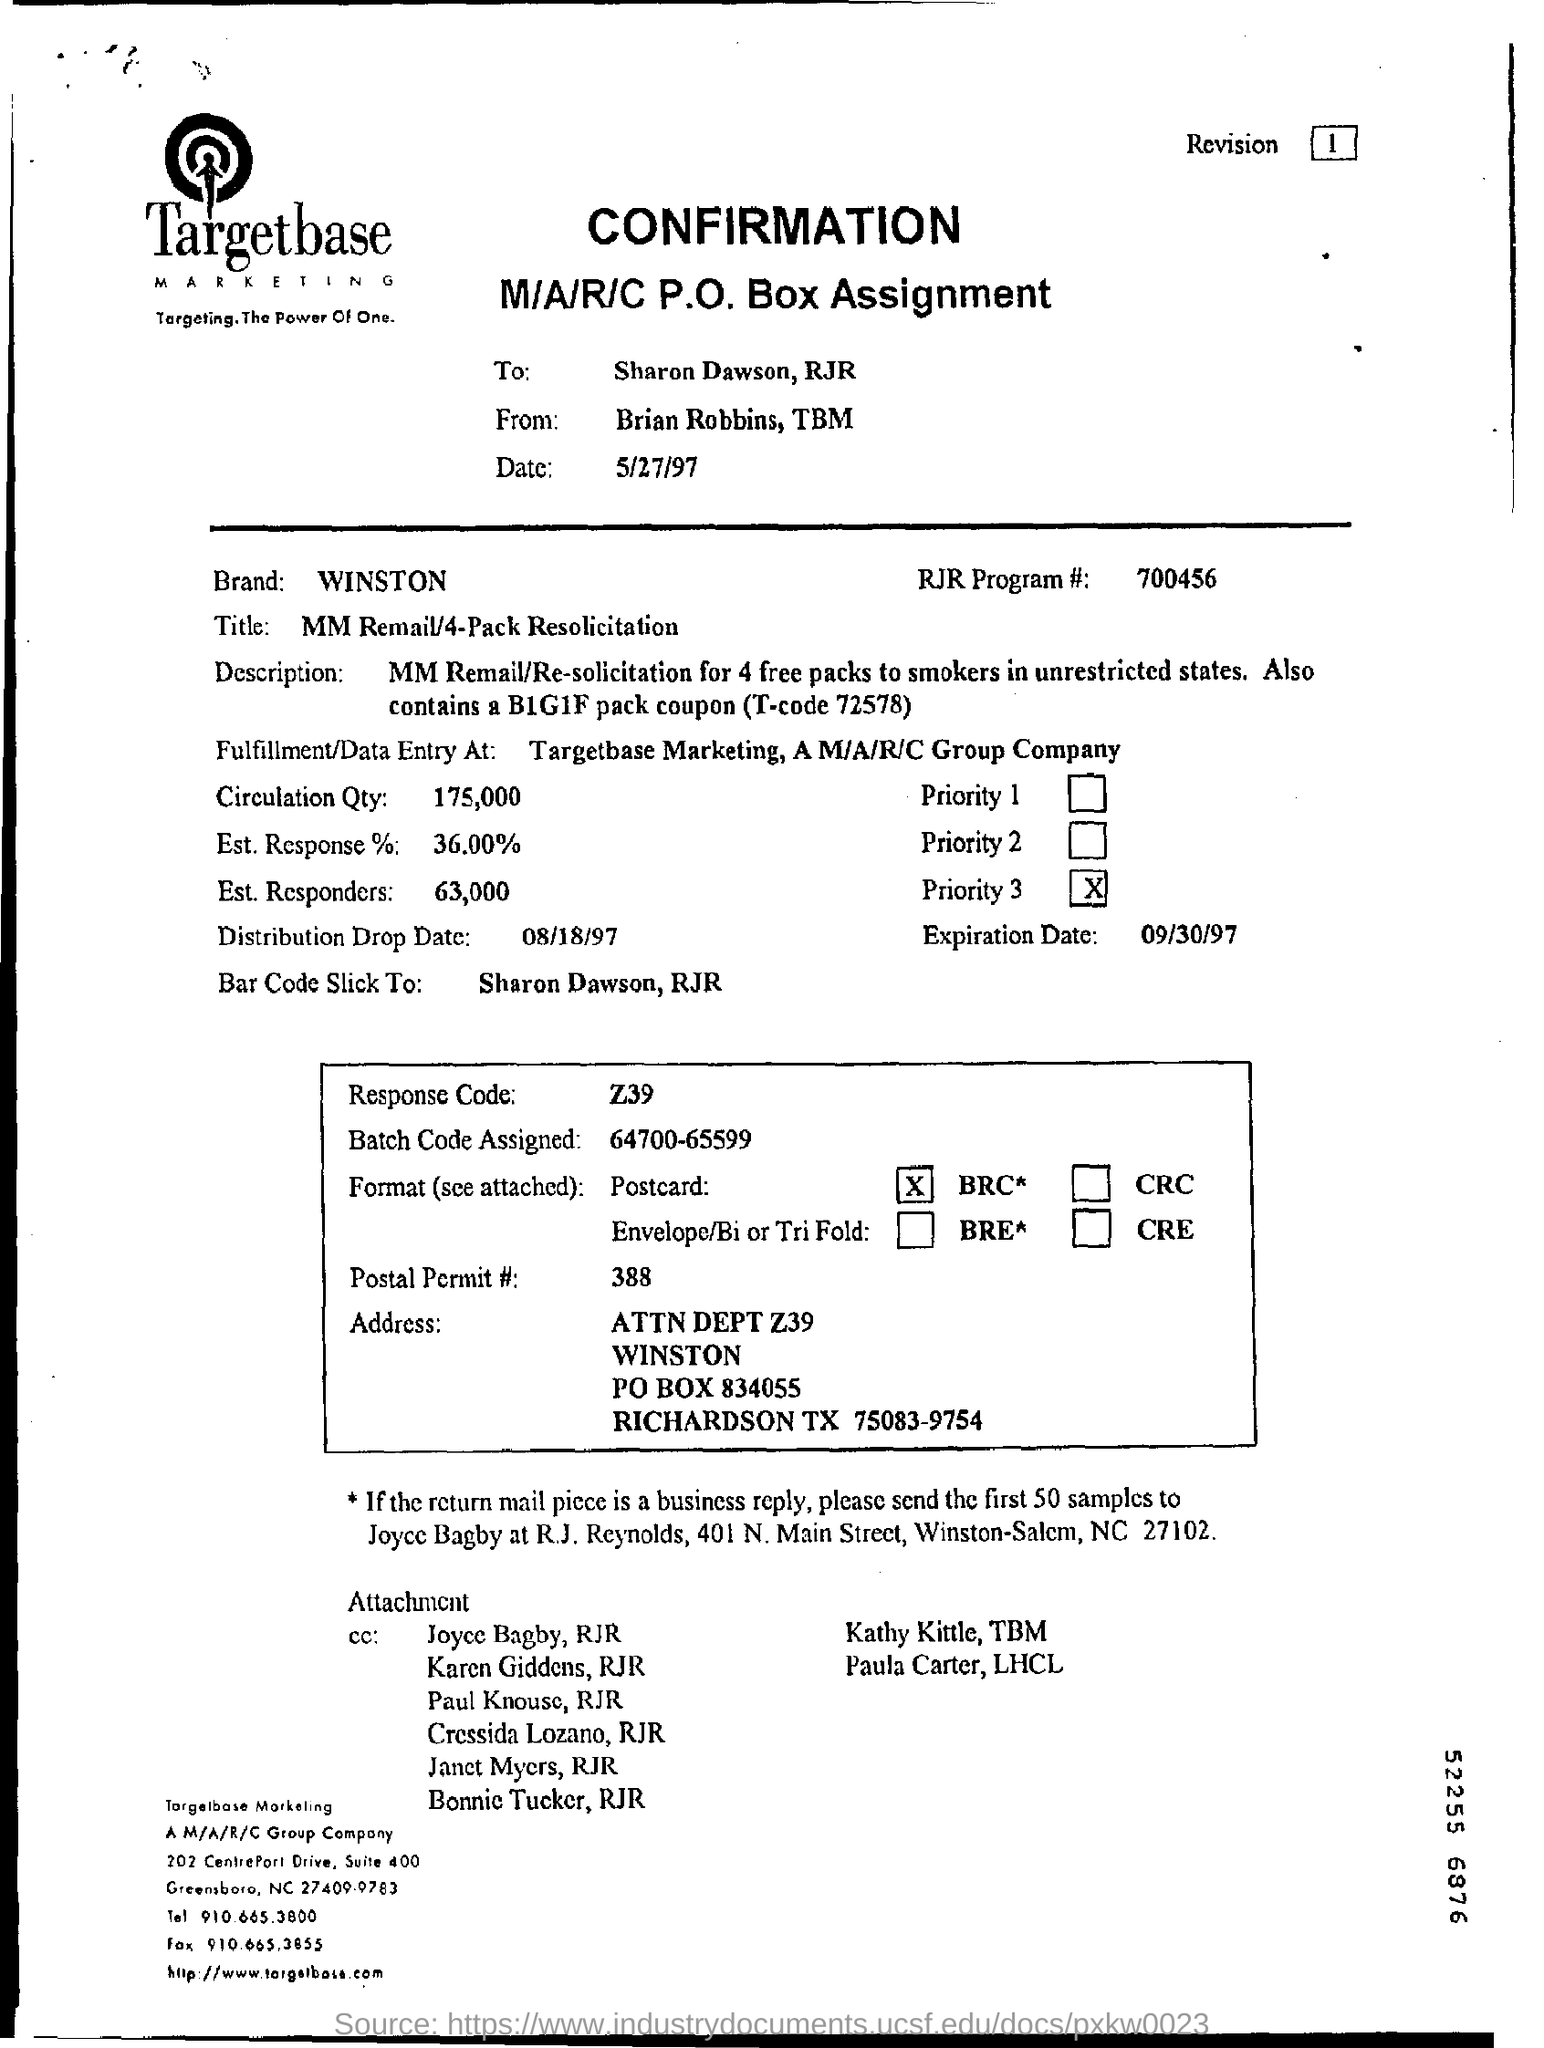Give some essential details in this illustration. What is the code for the RJR program? It is 700456... What is the response code? It is the Z39.50 standard. 